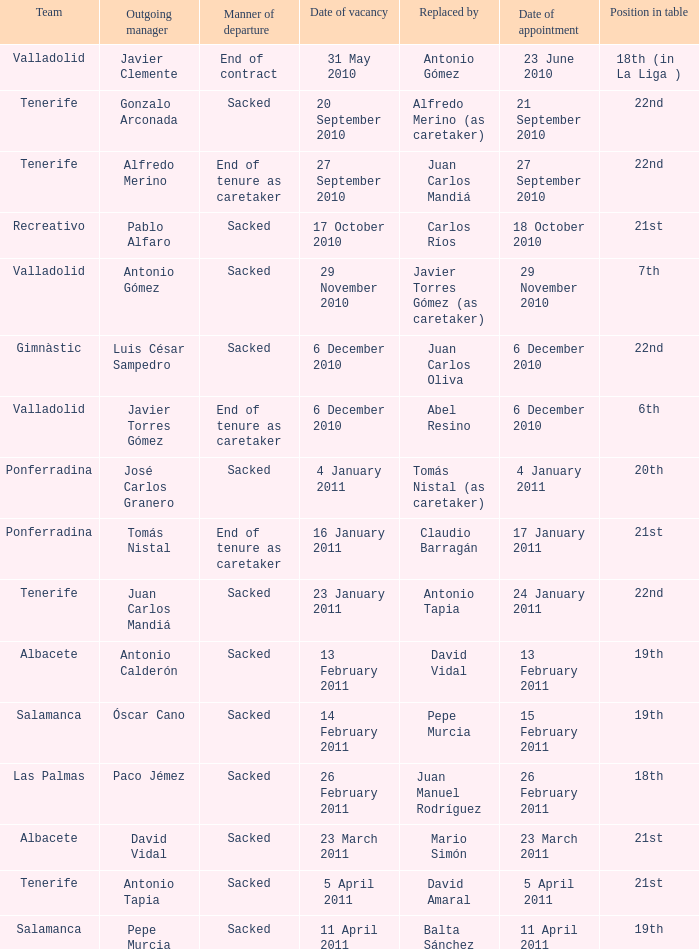In which capacity is alfredo merino serving as the outgoing manager? 22nd. 